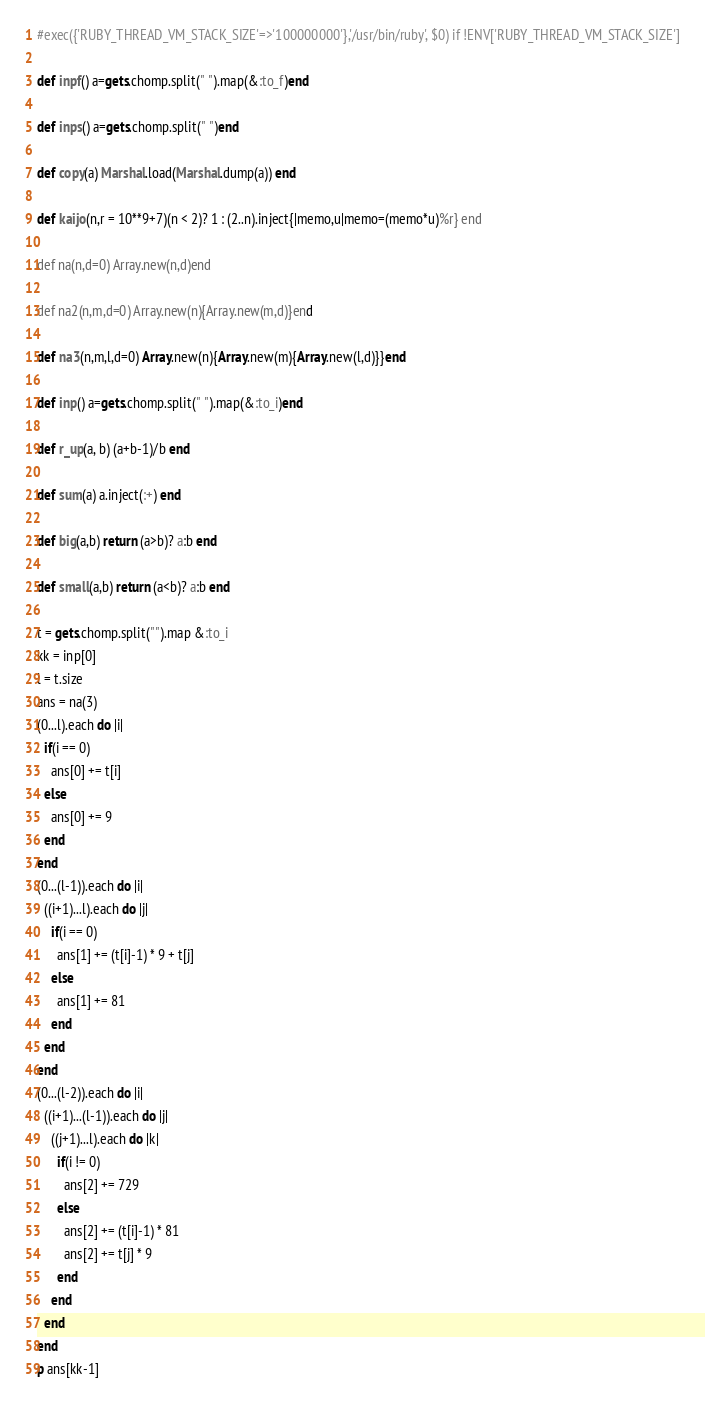<code> <loc_0><loc_0><loc_500><loc_500><_Ruby_>#exec({'RUBY_THREAD_VM_STACK_SIZE'=>'100000000'},'/usr/bin/ruby', $0) if !ENV['RUBY_THREAD_VM_STACK_SIZE']

def inpf() a=gets.chomp.split(" ").map(&:to_f)end

def inps() a=gets.chomp.split(" ")end

def copy(a) Marshal.load(Marshal.dump(a)) end

def kaijo(n,r = 10**9+7)(n < 2)? 1 : (2..n).inject{|memo,u|memo=(memo*u)%r} end

def na(n,d=0) Array.new(n,d)end

def na2(n,m,d=0) Array.new(n){Array.new(m,d)}end

def na3(n,m,l,d=0) Array.new(n){Array.new(m){Array.new(l,d)}}end

def inp() a=gets.chomp.split(" ").map(&:to_i)end

def r_up(a, b) (a+b-1)/b end

def sum(a) a.inject(:+) end

def big(a,b) return (a>b)? a:b end

def small(a,b) return (a<b)? a:b end

t = gets.chomp.split("").map &:to_i
kk = inp[0]
l = t.size
ans = na(3)
(0...l).each do |i|
  if(i == 0)
    ans[0] += t[i]
  else
    ans[0] += 9
  end
end
(0...(l-1)).each do |i|
  ((i+1)...l).each do |j|
    if(i == 0)
      ans[1] += (t[i]-1) * 9 + t[j]
    else
      ans[1] += 81
    end
  end
end
(0...(l-2)).each do |i|
  ((i+1)...(l-1)).each do |j|
    ((j+1)...l).each do |k|
      if(i != 0)
        ans[2] += 729
      else
        ans[2] += (t[i]-1) * 81
        ans[2] += t[j] * 9
      end
    end
  end
end
p ans[kk-1]

</code> 